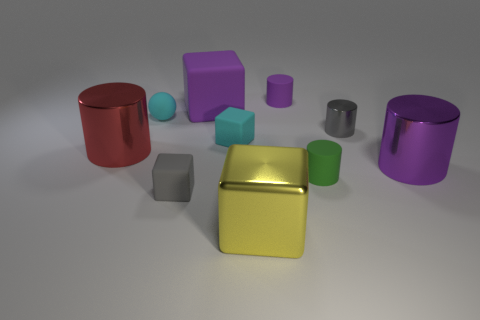Are there more red shiny things that are right of the large purple cylinder than tiny cylinders?
Give a very brief answer. No. There is a tiny matte cylinder behind the tiny gray cylinder; what color is it?
Your answer should be compact. Purple. There is a rubber thing that is the same color as the tiny ball; what is its size?
Make the answer very short. Small. What number of shiny objects are large purple cylinders or red things?
Offer a terse response. 2. Is there a big block that is behind the small gray object that is in front of the large cylinder on the right side of the big yellow metal cube?
Make the answer very short. Yes. How many large objects are on the right side of the ball?
Offer a very short reply. 3. What material is the tiny cube that is the same color as the tiny metallic cylinder?
Make the answer very short. Rubber. What number of large objects are either yellow shiny cubes or gray spheres?
Provide a short and direct response. 1. What is the shape of the tiny gray object behind the red cylinder?
Your response must be concise. Cylinder. Is there a tiny object that has the same color as the big metallic block?
Keep it short and to the point. No. 